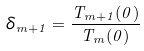Convert formula to latex. <formula><loc_0><loc_0><loc_500><loc_500>\delta _ { m + 1 } = \frac { T _ { m + 1 } ( 0 ) } { T _ { m } ( 0 ) }</formula> 